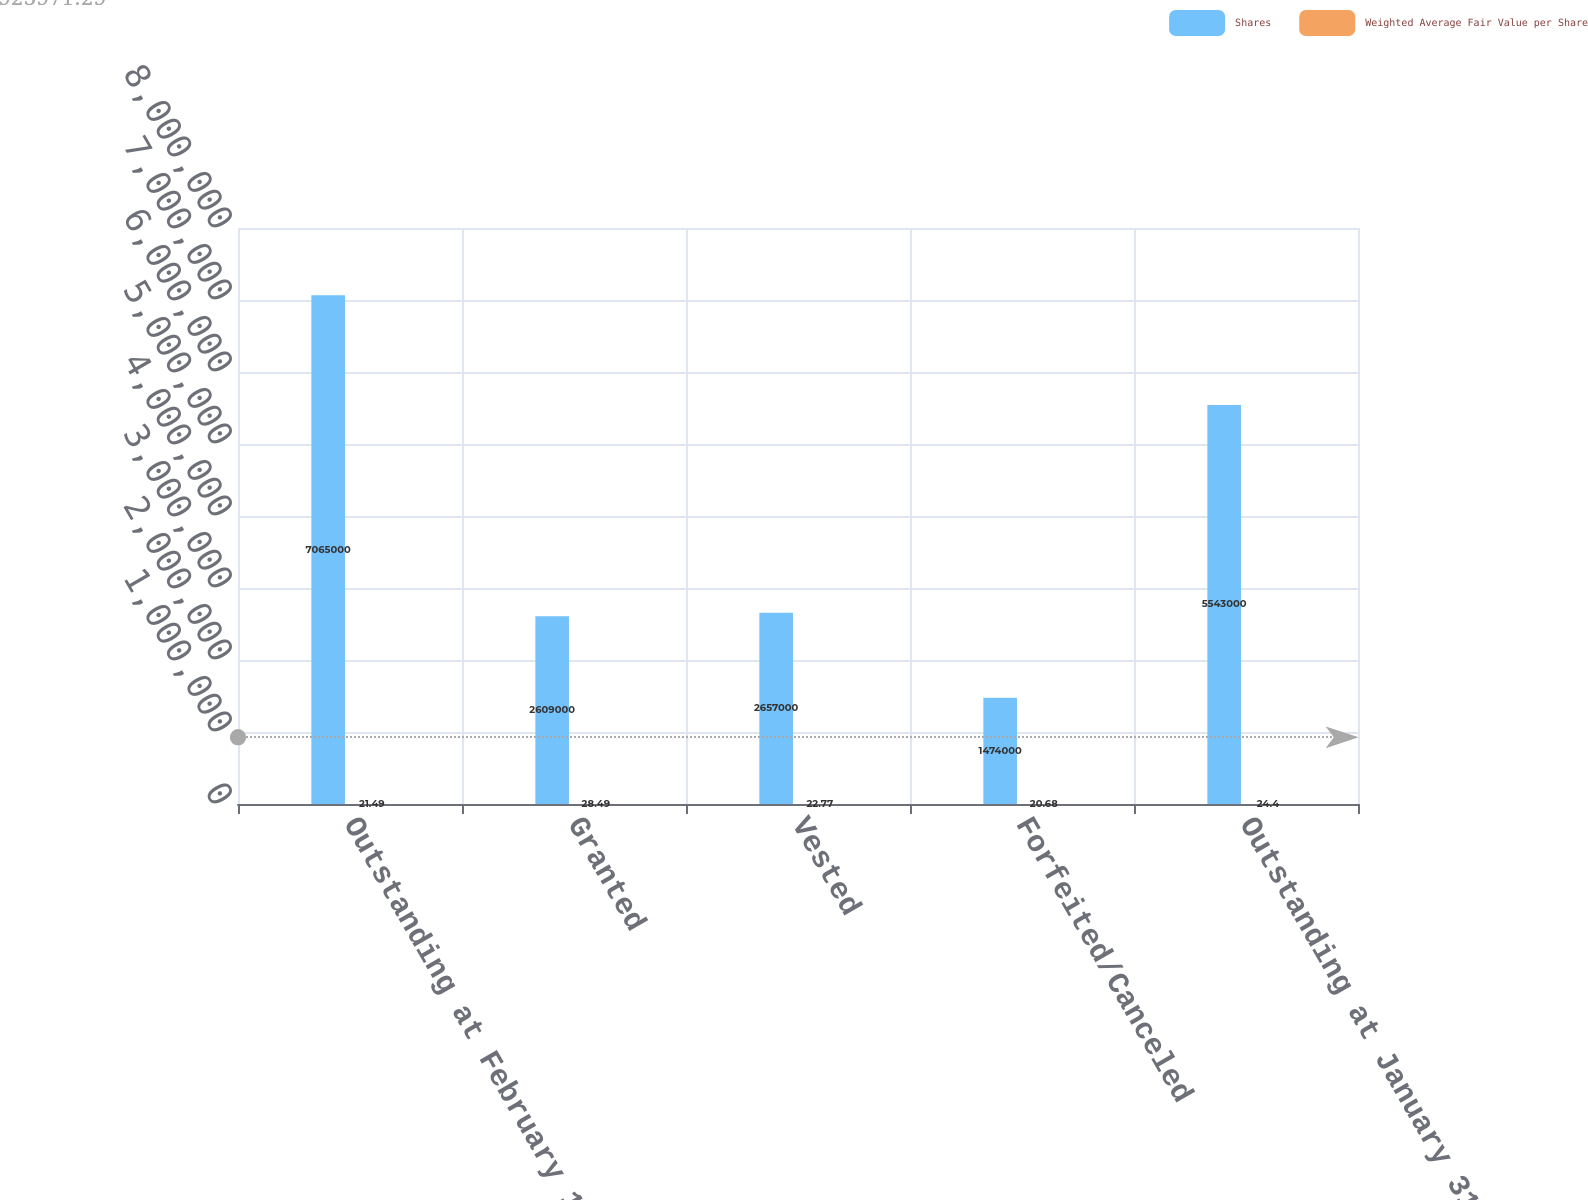Convert chart. <chart><loc_0><loc_0><loc_500><loc_500><stacked_bar_chart><ecel><fcel>Outstanding at February 1 2014<fcel>Granted<fcel>Vested<fcel>Forfeited/Canceled<fcel>Outstanding at January 31 2015<nl><fcel>Shares<fcel>7.065e+06<fcel>2.609e+06<fcel>2.657e+06<fcel>1.474e+06<fcel>5.543e+06<nl><fcel>Weighted Average Fair Value per Share<fcel>21.49<fcel>28.49<fcel>22.77<fcel>20.68<fcel>24.4<nl></chart> 